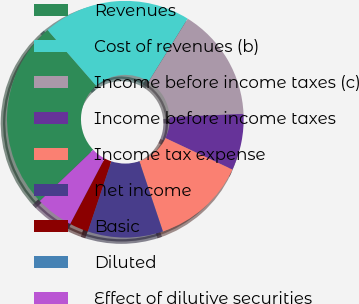<chart> <loc_0><loc_0><loc_500><loc_500><pie_chart><fcel>Revenues<fcel>Cost of revenues (b)<fcel>Income before income taxes (c)<fcel>Income before income taxes<fcel>Income tax expense<fcel>Net income<fcel>Basic<fcel>Diluted<fcel>Effect of dilutive securities<nl><fcel>25.73%<fcel>20.25%<fcel>15.44%<fcel>7.72%<fcel>12.86%<fcel>10.29%<fcel>2.57%<fcel>0.0%<fcel>5.15%<nl></chart> 